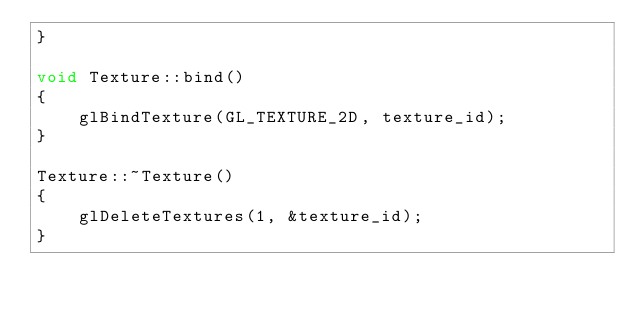Convert code to text. <code><loc_0><loc_0><loc_500><loc_500><_C++_>}

void Texture::bind()
{
    glBindTexture(GL_TEXTURE_2D, texture_id);
}

Texture::~Texture()
{
    glDeleteTextures(1, &texture_id);
}
</code> 